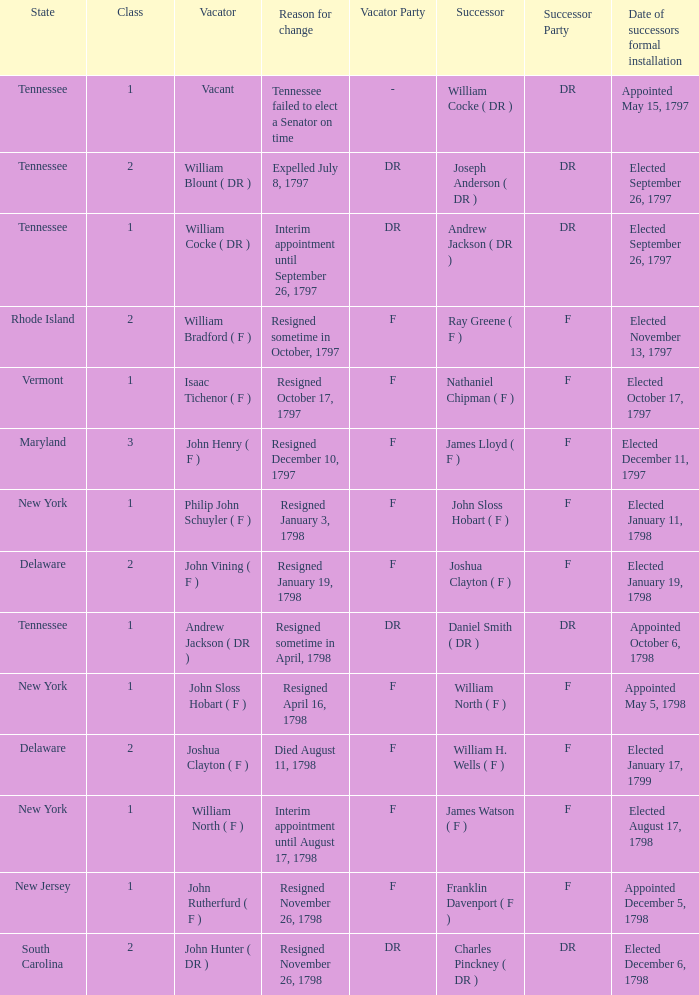What is the number of vacators when the successor was William H. Wells ( F )? 1.0. 